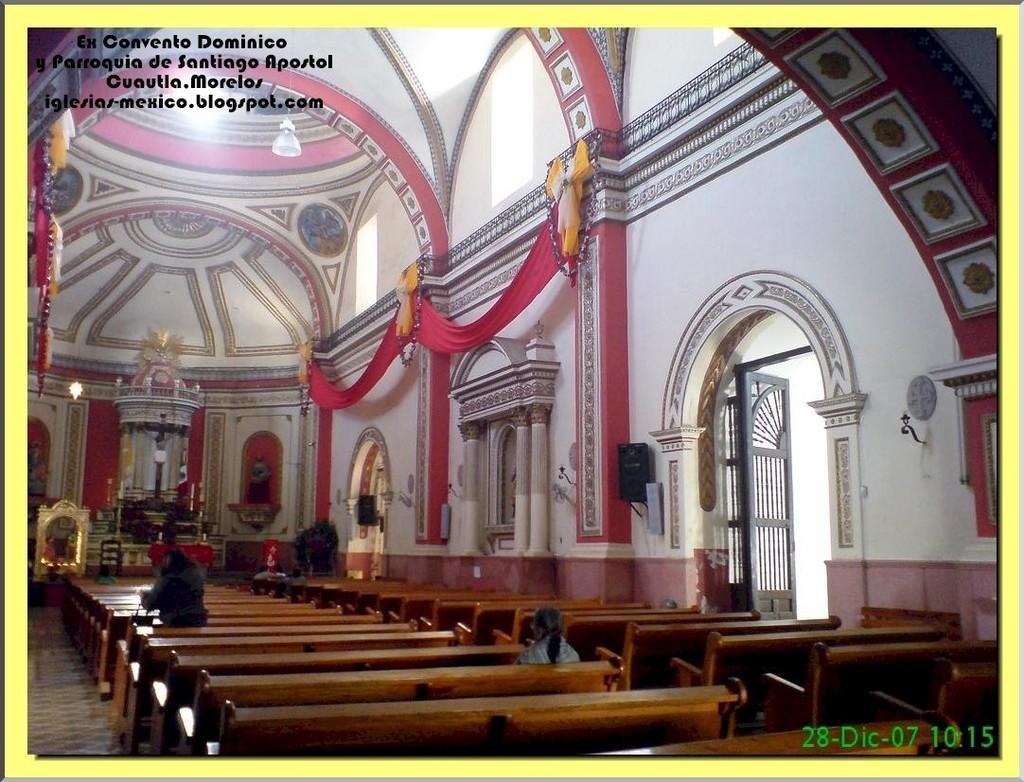Can you describe this image briefly? In this picture we can see inside view of a building, here we can see people, benches, curtains, door, wall, speakers, garlands, lights, wall and some objects, in the top left and bottom right we can see some text and numbers on it. 